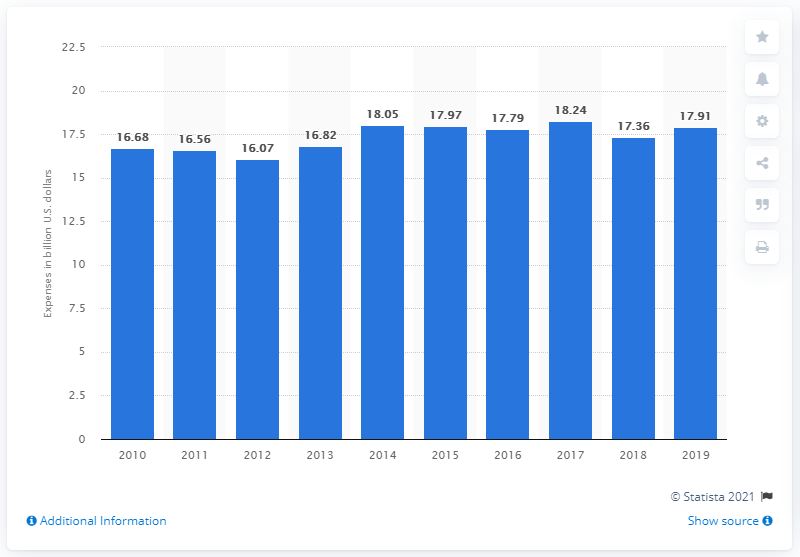List a handful of essential elements in this visual. The annual expenses of book publishers in the previous year were 17.36 dollars. In 2019, book publishers in the United States spent 17.91 on expenses. 